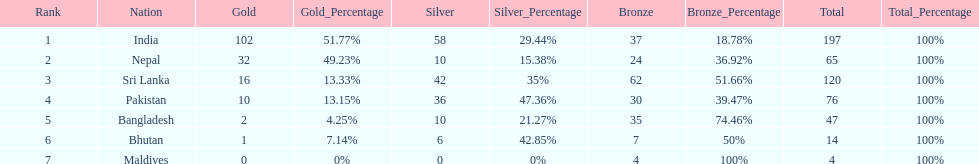Name a country listed in the table, other than india? Nepal. 